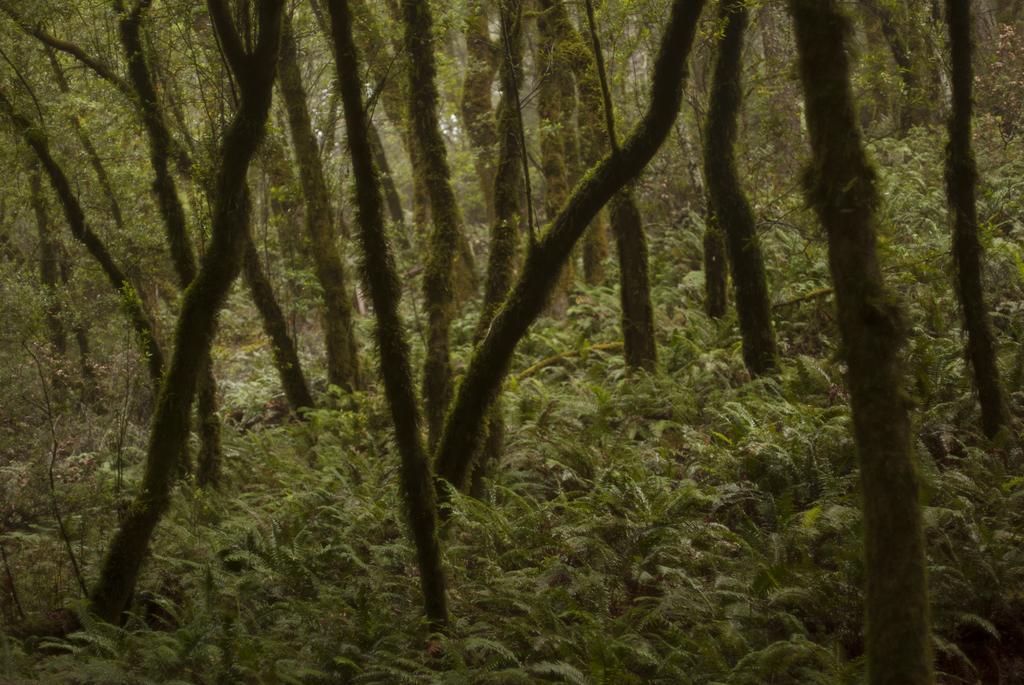Can you describe this image briefly? In this image, we can see trees and plants. 